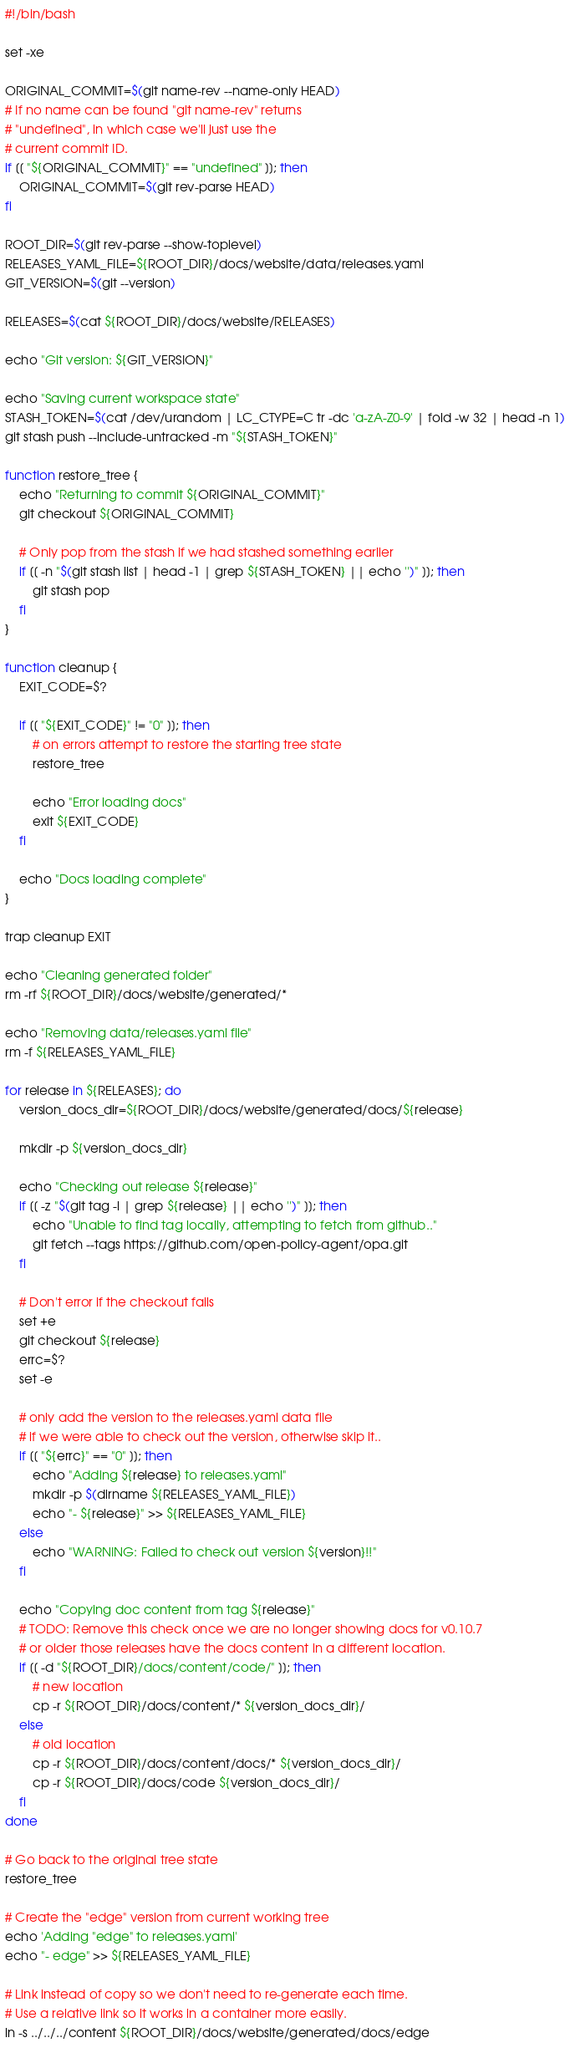Convert code to text. <code><loc_0><loc_0><loc_500><loc_500><_Bash_>#!/bin/bash

set -xe

ORIGINAL_COMMIT=$(git name-rev --name-only HEAD)
# If no name can be found "git name-rev" returns
# "undefined", in which case we'll just use the
# current commit ID.
if [[ "${ORIGINAL_COMMIT}" == "undefined" ]]; then
    ORIGINAL_COMMIT=$(git rev-parse HEAD)
fi

ROOT_DIR=$(git rev-parse --show-toplevel)
RELEASES_YAML_FILE=${ROOT_DIR}/docs/website/data/releases.yaml
GIT_VERSION=$(git --version)

RELEASES=$(cat ${ROOT_DIR}/docs/website/RELEASES)

echo "Git version: ${GIT_VERSION}"

echo "Saving current workspace state"
STASH_TOKEN=$(cat /dev/urandom | LC_CTYPE=C tr -dc 'a-zA-Z0-9' | fold -w 32 | head -n 1)
git stash push --include-untracked -m "${STASH_TOKEN}"

function restore_tree {
    echo "Returning to commit ${ORIGINAL_COMMIT}"
    git checkout ${ORIGINAL_COMMIT}

    # Only pop from the stash if we had stashed something earlier
    if [[ -n "$(git stash list | head -1 | grep ${STASH_TOKEN} || echo '')" ]]; then
        git stash pop
    fi
}

function cleanup {
    EXIT_CODE=$?

    if [[ "${EXIT_CODE}" != "0" ]]; then 
        # on errors attempt to restore the starting tree state
        restore_tree

        echo "Error loading docs"
        exit ${EXIT_CODE}
    fi

    echo "Docs loading complete"
}

trap cleanup EXIT

echo "Cleaning generated folder"
rm -rf ${ROOT_DIR}/docs/website/generated/*

echo "Removing data/releases.yaml file"
rm -f ${RELEASES_YAML_FILE}

for release in ${RELEASES}; do
    version_docs_dir=${ROOT_DIR}/docs/website/generated/docs/${release}

    mkdir -p ${version_docs_dir}

    echo "Checking out release ${release}"
    if [[ -z "$(git tag -l | grep ${release} || echo '')" ]]; then
        echo "Unable to find tag locally, attempting to fetch from github.."
        git fetch --tags https://github.com/open-policy-agent/opa.git
    fi

    # Don't error if the checkout fails
    set +e
    git checkout ${release}
    errc=$?
    set -e

    # only add the version to the releases.yaml data file
    # if we were able to check out the version, otherwise skip it..
    if [[ "${errc}" == "0" ]]; then
        echo "Adding ${release} to releases.yaml"
        mkdir -p $(dirname ${RELEASES_YAML_FILE})
        echo "- ${release}" >> ${RELEASES_YAML_FILE}
    else
        echo "WARNING: Failed to check out version ${version}!!"
    fi

    echo "Copying doc content from tag ${release}"
    # TODO: Remove this check once we are no longer showing docs for v0.10.7 
    # or older those releases have the docs content in a different location.
    if [[ -d "${ROOT_DIR}/docs/content/code/" ]]; then
        # new location
        cp -r ${ROOT_DIR}/docs/content/* ${version_docs_dir}/
    else
        # old location
        cp -r ${ROOT_DIR}/docs/content/docs/* ${version_docs_dir}/
        cp -r ${ROOT_DIR}/docs/code ${version_docs_dir}/
    fi
done

# Go back to the original tree state
restore_tree

# Create the "edge" version from current working tree
echo 'Adding "edge" to releases.yaml'
echo "- edge" >> ${RELEASES_YAML_FILE}

# Link instead of copy so we don't need to re-generate each time.
# Use a relative link so it works in a container more easily.
ln -s ../../../content ${ROOT_DIR}/docs/website/generated/docs/edge
</code> 